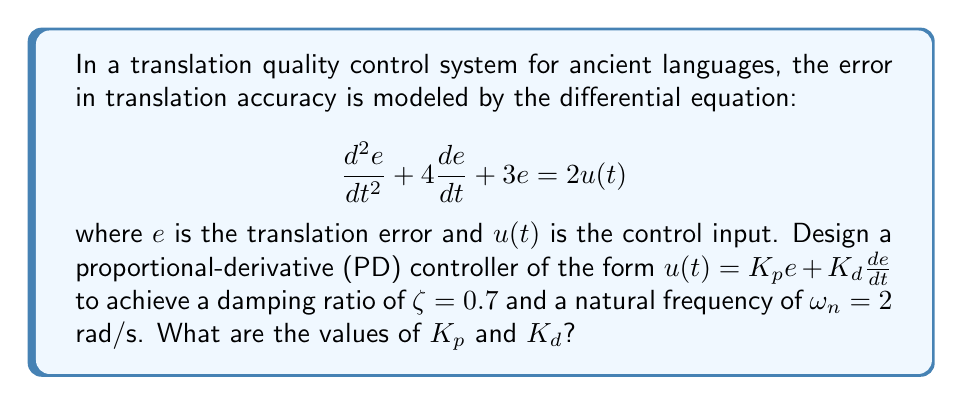Give your solution to this math problem. To solve this problem, we'll follow these steps:

1) The closed-loop characteristic equation for a second-order system is:

   $$s^2 + 2\zeta\omega_n s + \omega_n^2 = 0$$

2) Our system with the PD controller becomes:

   $$\frac{d^2e}{dt^2} + 4\frac{de}{dt} + 3e = 2(K_p e + K_d \frac{de}{dt})$$

   Rearranging:

   $$\frac{d^2e}{dt^2} + (4-2K_d)\frac{de}{dt} + (3-2K_p)e = 0$$

3) Comparing this with the standard form, we get:

   $$2\zeta\omega_n = 4-2K_d$$
   $$\omega_n^2 = 3-2K_p$$

4) Given $\zeta = 0.7$ and $\omega_n = 2$ rad/s, we can solve these equations:

   $$2(0.7)(2) = 4-2K_d$$
   $$2.8 = 4-2K_d$$
   $$2K_d = 1.2$$
   $$K_d = 0.6$$

   $$2^2 = 3-2K_p$$
   $$4 = 3-2K_p$$
   $$2K_p = -1$$
   $$K_p = -0.5$$

5) Therefore, the PD controller gains are $K_p = -0.5$ and $K_d = 0.6$.
Answer: $K_p = -0.5$, $K_d = 0.6$ 